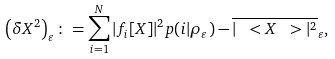<formula> <loc_0><loc_0><loc_500><loc_500>\left ( \delta X ^ { 2 } \right ) _ { \varepsilon } \colon = \sum _ { i = 1 } ^ { N } | f _ { i } [ X ] | ^ { 2 } p ( i | \rho _ { \varepsilon } ) - \overline { | \ < X \ > | ^ { 2 } } _ { \varepsilon } ,</formula> 